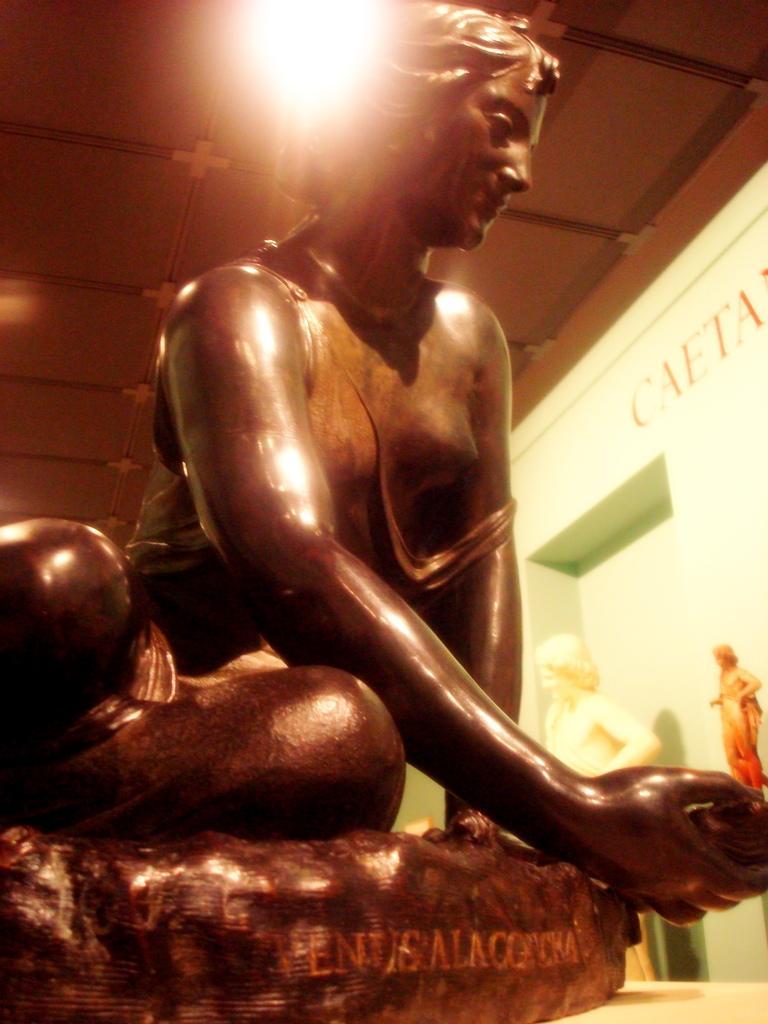In one or two sentences, can you explain what this image depicts? In this image we can see the depiction of a woman and some text on it, behind that there is an another statue in front of the wall with some text and an image. At the top of the image there is a ceiling. 